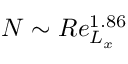<formula> <loc_0><loc_0><loc_500><loc_500>N \sim R e _ { L _ { x } } ^ { 1 . 8 6 }</formula> 